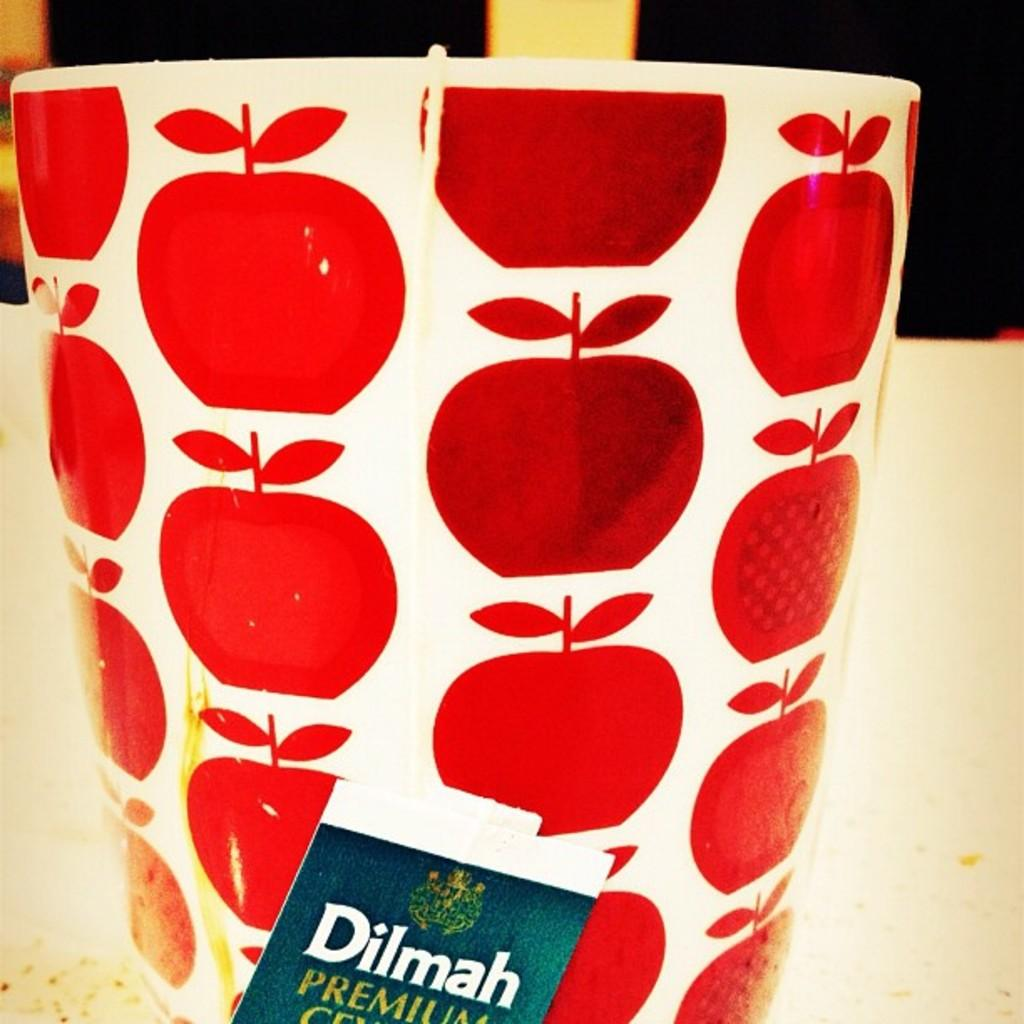What object is present in the image? There is a cup in the image. What design is on the cup? The cup has apple images on it. What is inside the cup? There is a tea bag inside the cup. Can you see any ocean waves in the image? There is no ocean or waves present in the image; it features a cup with apple images and a tea bag inside. 